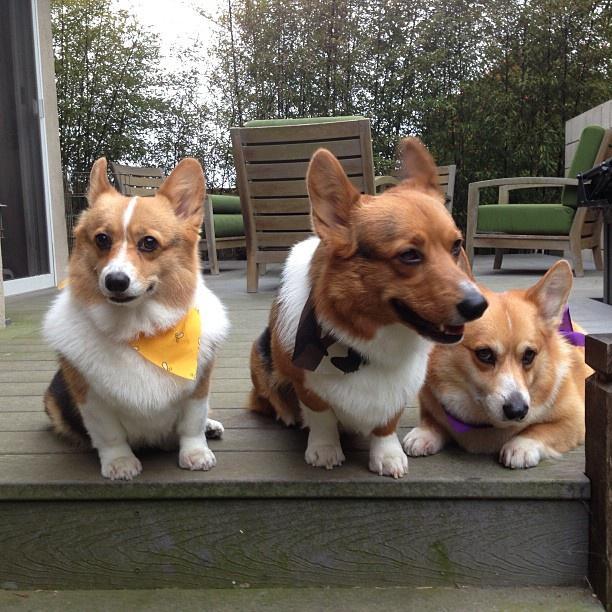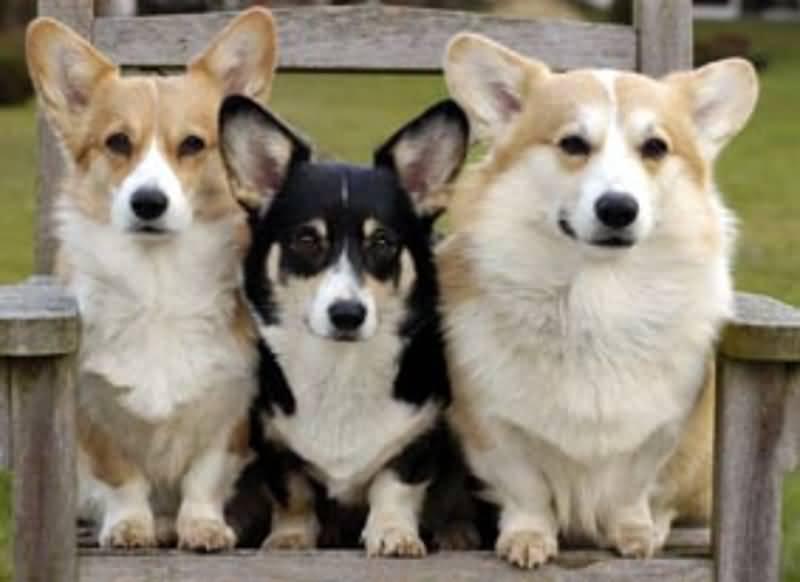The first image is the image on the left, the second image is the image on the right. Given the left and right images, does the statement "At least one dog has its tongue sticking out of its mouth." hold true? Answer yes or no. No. The first image is the image on the left, the second image is the image on the right. Assess this claim about the two images: "An image shows exactly one short-legged dog, which is standing in the grass.". Correct or not? Answer yes or no. No. 